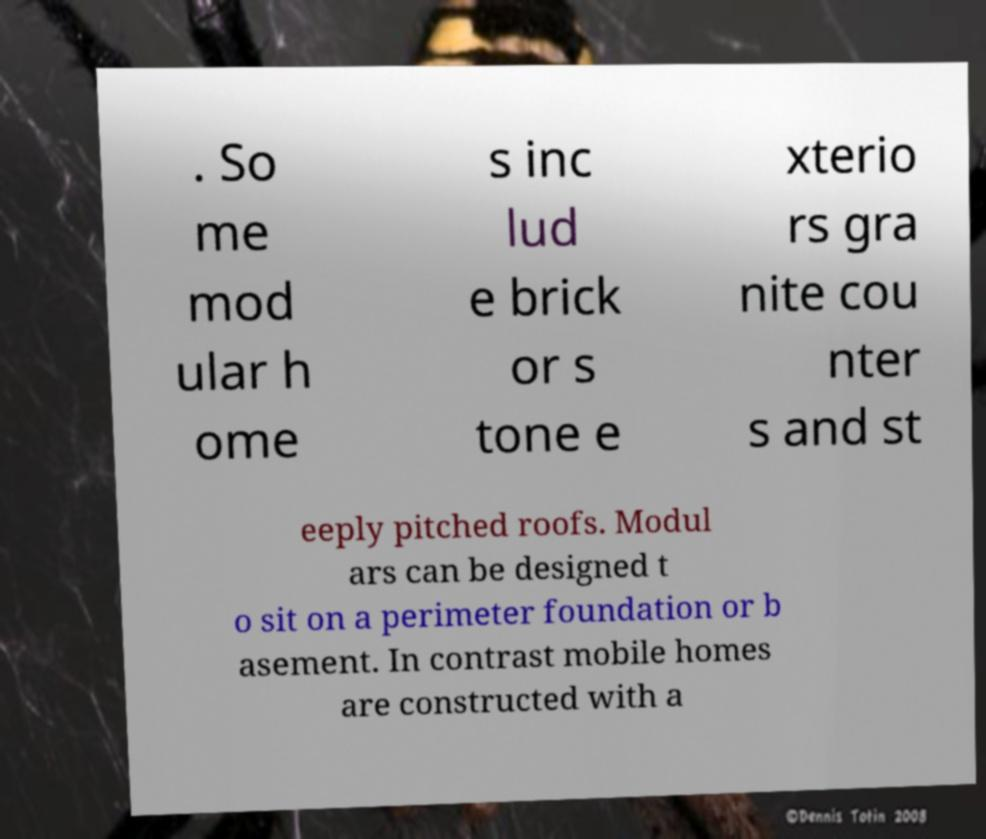For documentation purposes, I need the text within this image transcribed. Could you provide that? . So me mod ular h ome s inc lud e brick or s tone e xterio rs gra nite cou nter s and st eeply pitched roofs. Modul ars can be designed t o sit on a perimeter foundation or b asement. In contrast mobile homes are constructed with a 